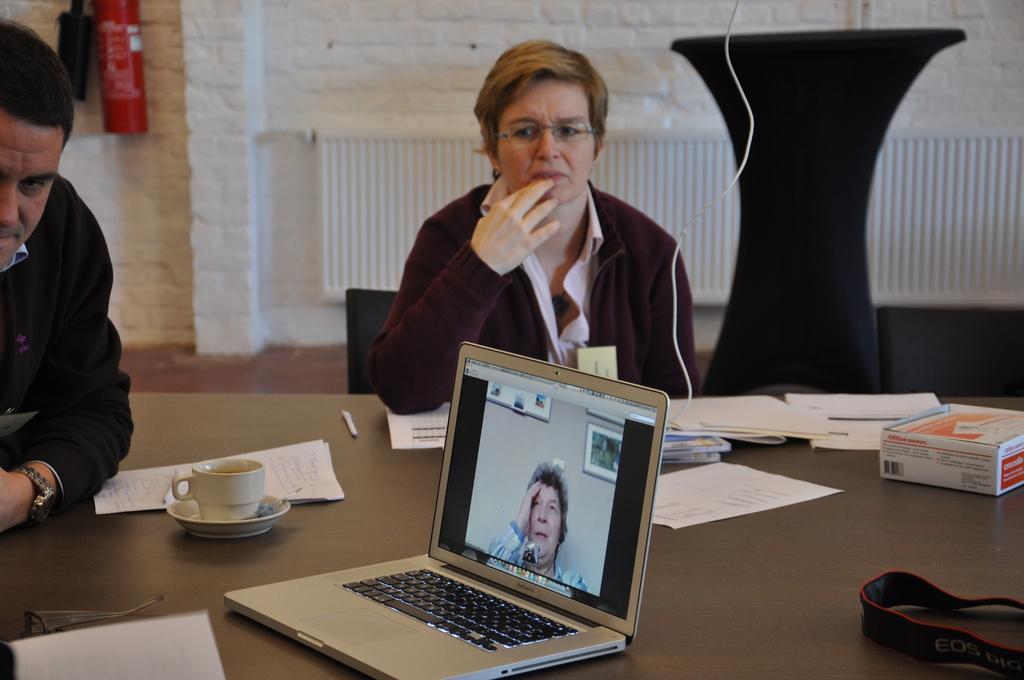How would you summarize this image in a sentence or two? In the middle of the image a woman is sitting on a chair. Bottom left side of the image a man is sitting. Bottom of the image there is a table, On the table there are some papers, laptop and cup and saucer. Behind them there is a wall. On the wall there is a fire extinguisher. 